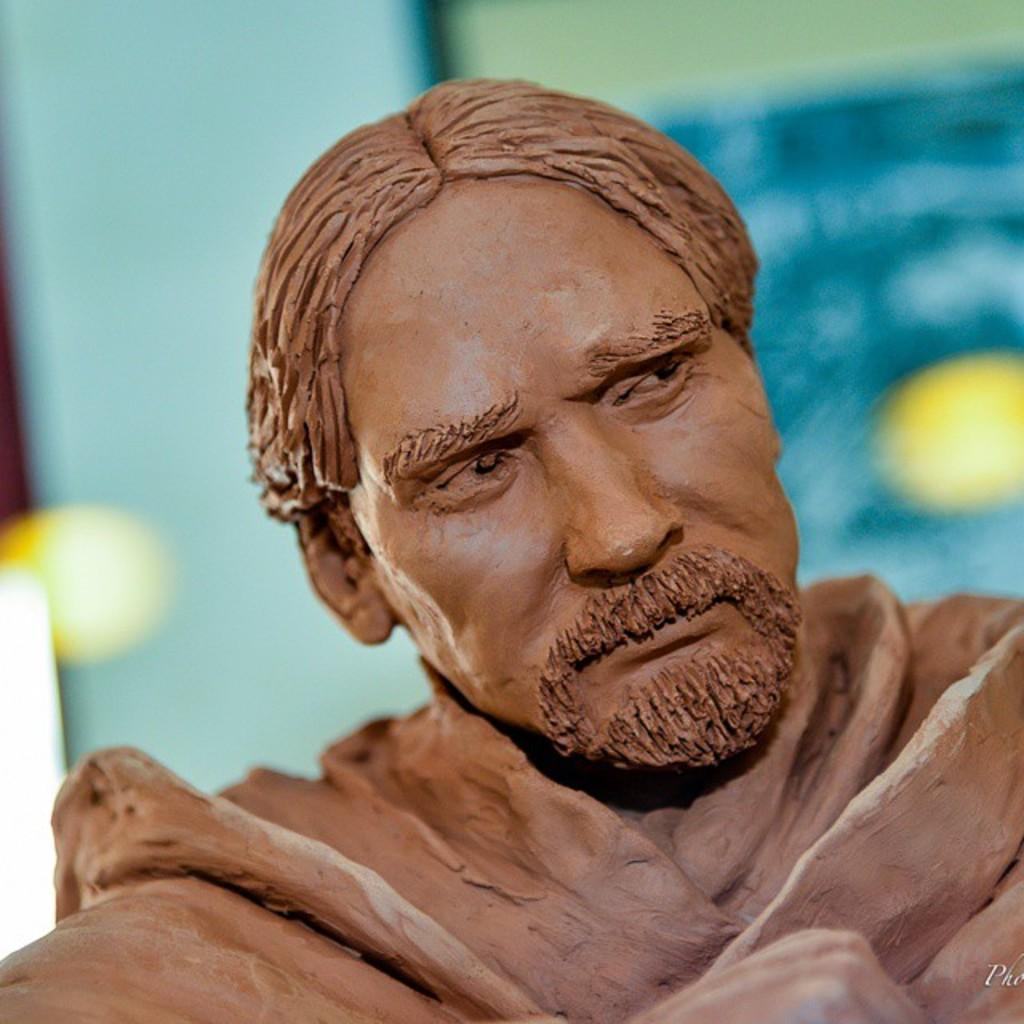What is the main subject of the image? There is a statue of a man in the image. Can you describe the background of the image? The background of the image is blurred. How many divisions of cats can be seen in the image? There are no cats present in the image, so it is not possible to determine the number of divisions of cats. 